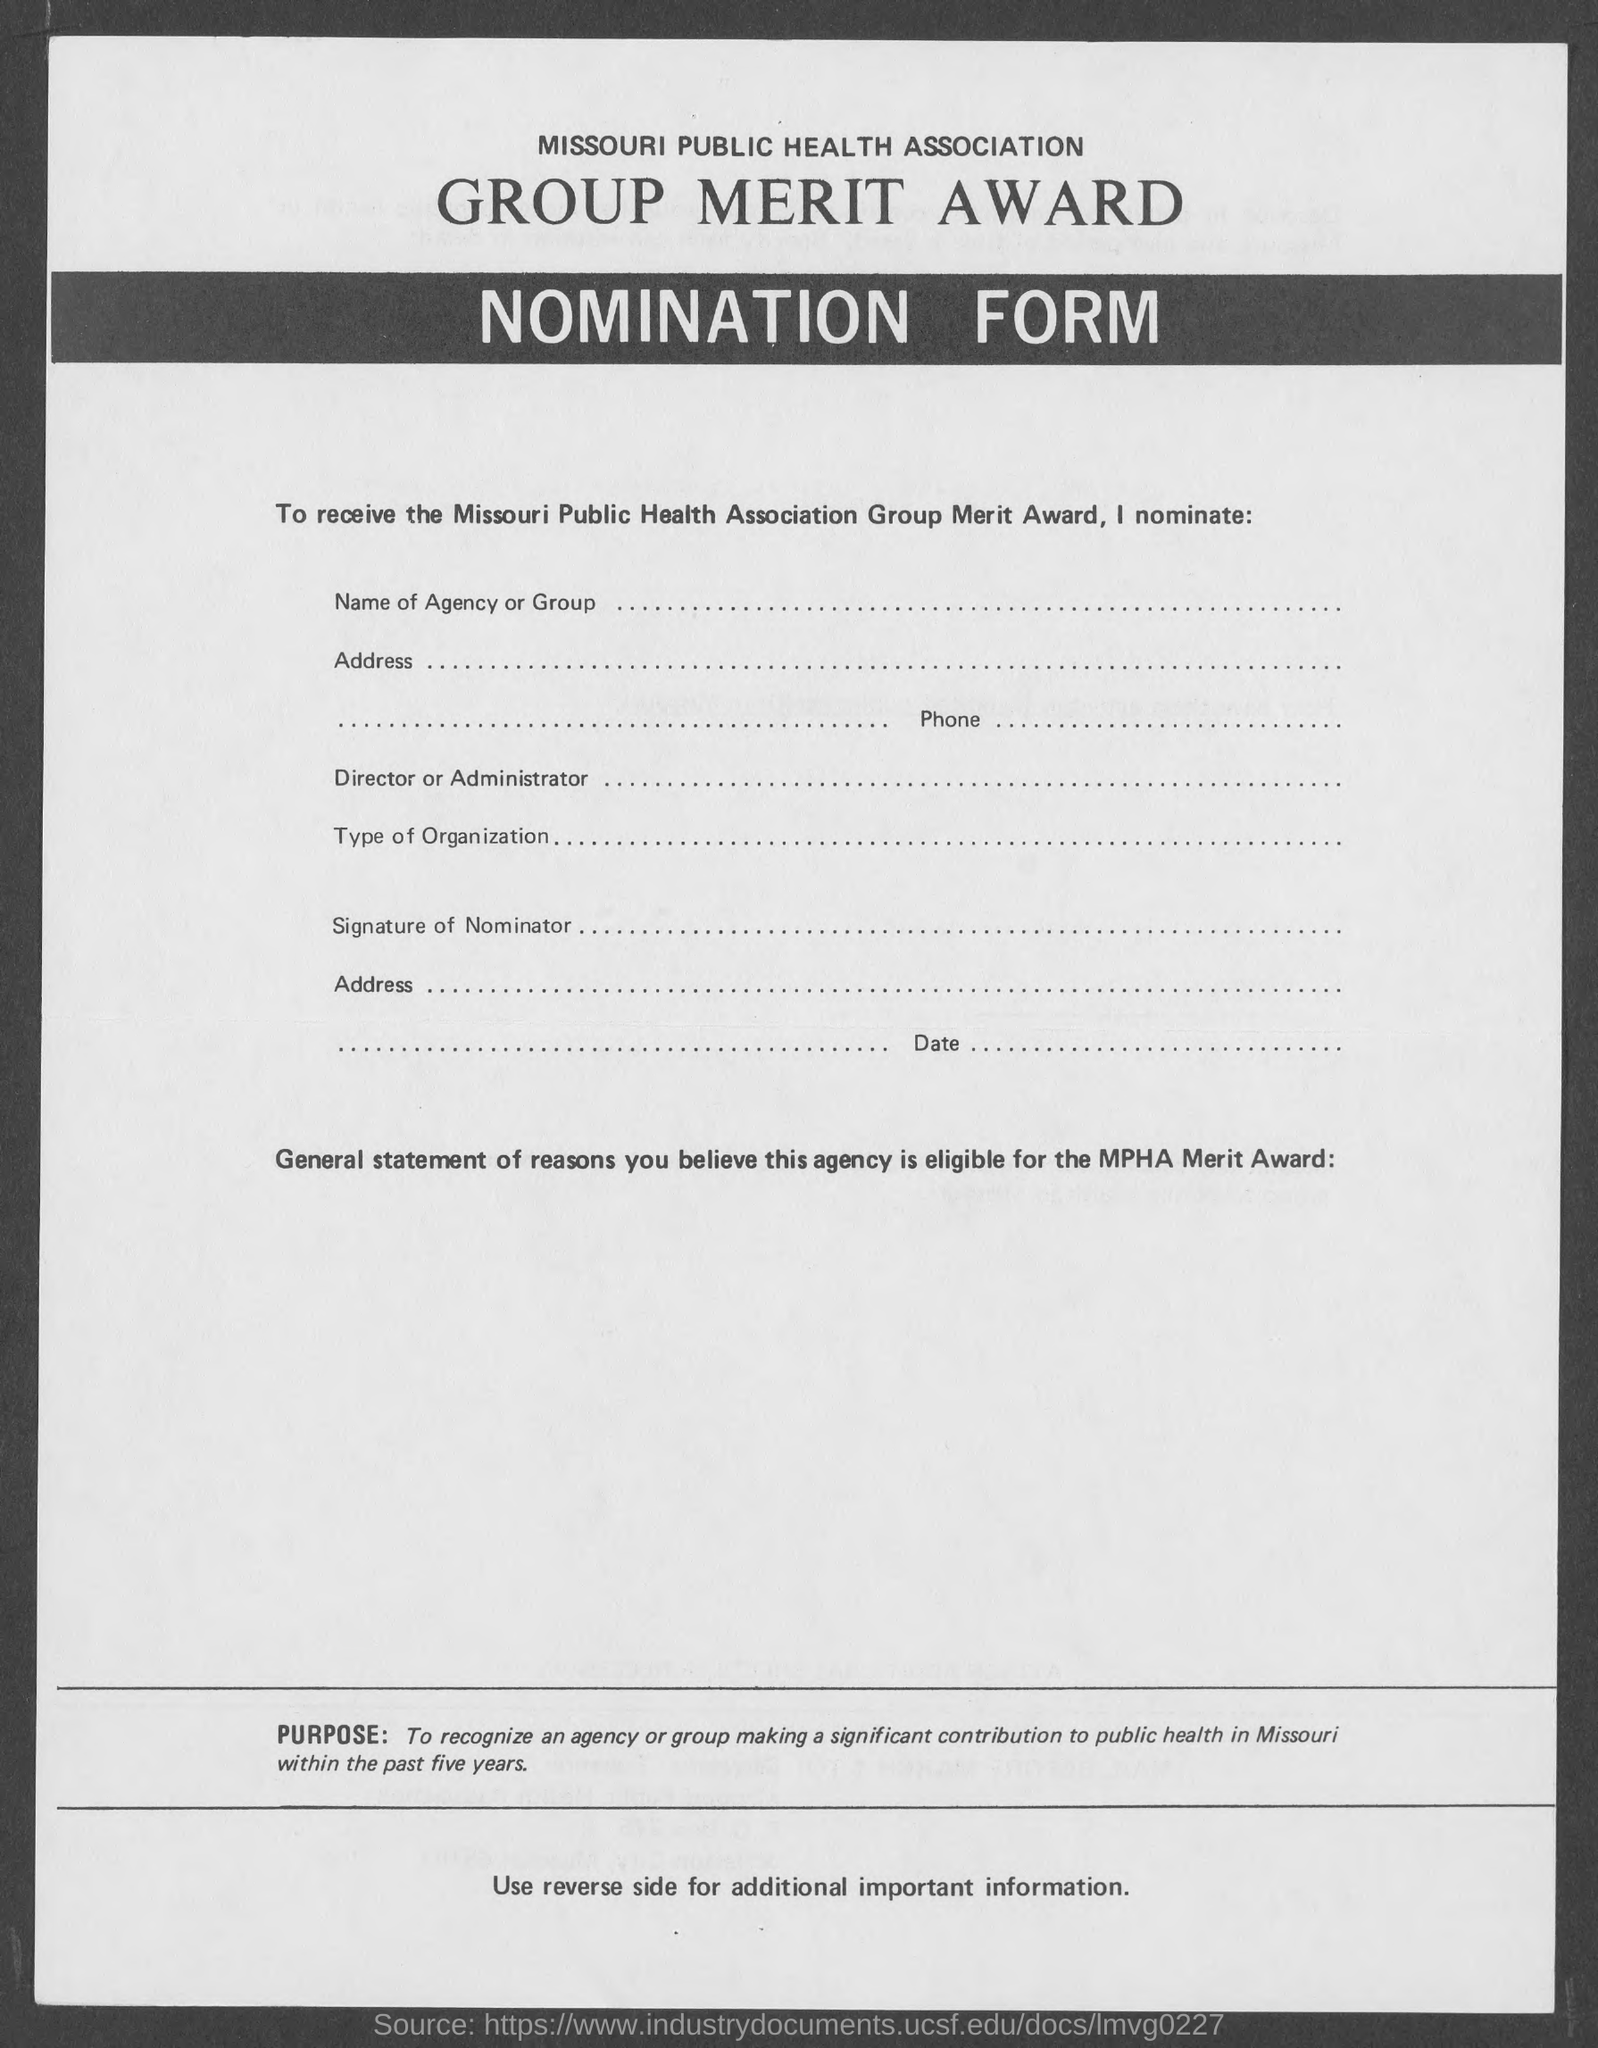Outline some significant characteristics in this image. The form named 'Nomination form' is what. 